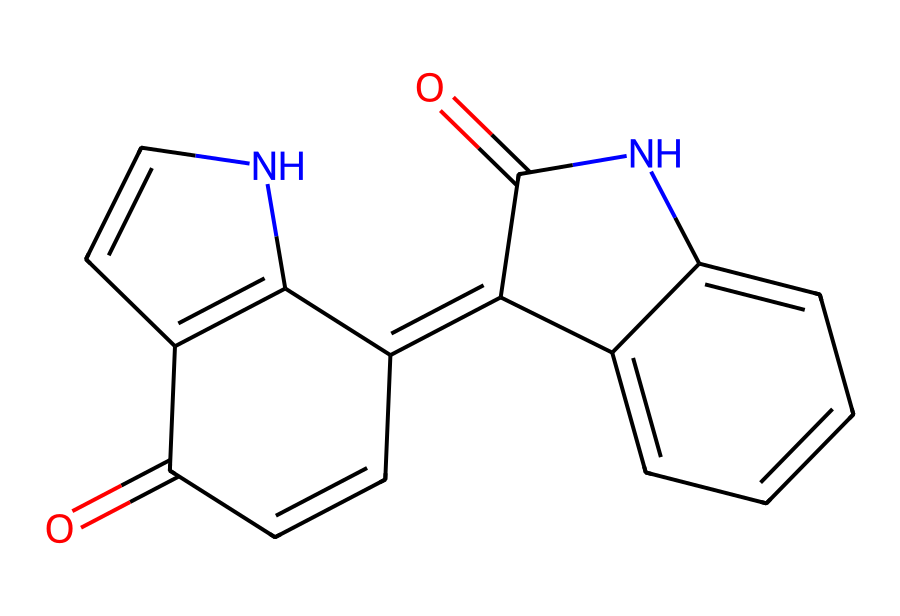What is the molecular formula of indigo dye as represented by the SMILES? To determine the molecular formula from the SMILES representation, we count the number of each type of atom present in the structure. The SMILES shows that there are 14 carbon atoms (C), 8 hydrogen atoms (H), 2 nitrogen atoms (N), and 4 oxygen atoms (O). Combining these gives the molecular formula C14H8N2O4.
Answer: C14H8N2O4 How many nitrogen atoms are in the structure? Looking at the SMILES representation, the 'N' symbols represent nitrogen atoms, and there are exactly 2 'N' instances in the structure. Therefore, there are 2 nitrogen atoms in the chemical structure of indigo dye.
Answer: 2 What type of chemical compound is indigo dye classified as? Indigo dye is categorized as a dye, and more specifically, it is an organic compound known for its color properties derived from its aromatic and conjugated structure, which is indicated by the multiple interconnected rings in the SMILES.
Answer: dye What is the total number of rings present in the indigo dye structure? By analyzing the SMILES for the presence of cyclic structures, we see that there are three distinct ring closures (indicated by the numbers in the SMILES). Thus, there are a total of three rings present in the structure.
Answer: 3 What type of bonding is primarily present in the indigo dye structure? The structure features a combination of double bonds (between carbon and nitrogen) as seen in the multiple occurrences of '=' in the SMILES representation, indicating the presence of conjugated systems and aromatic properties, which are characteristic of many dyes, including indigo.
Answer: double bonds What characteristic property does indigo contribute to textiles from the chemical structure? The chemical structure of indigo, particularly its conjugated system and absence of a hydroxyl group (OH) directly bonded to the aromatic rings, creates a compound that is renowned for its excellent dyeing properties, providing rich blue shades to textiles.
Answer: blue dye 